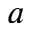<formula> <loc_0><loc_0><loc_500><loc_500>^ { a }</formula> 